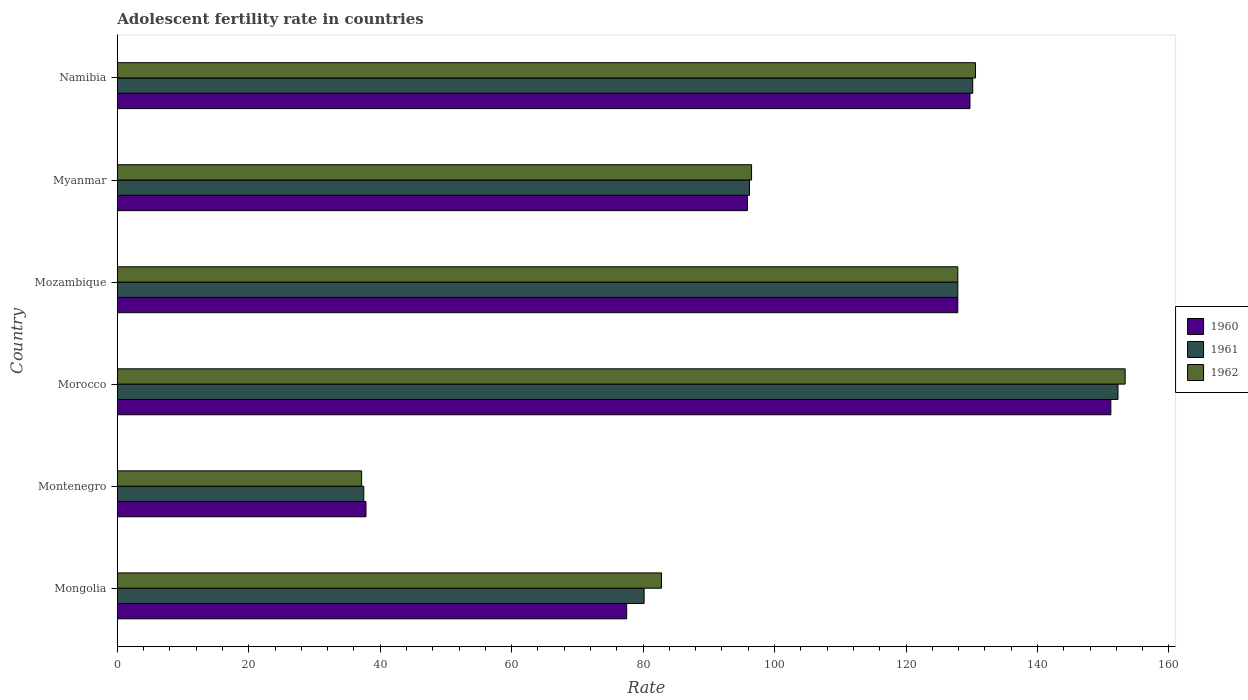How many different coloured bars are there?
Give a very brief answer. 3. Are the number of bars on each tick of the Y-axis equal?
Keep it short and to the point. Yes. How many bars are there on the 3rd tick from the bottom?
Your response must be concise. 3. What is the label of the 4th group of bars from the top?
Offer a terse response. Morocco. What is the adolescent fertility rate in 1961 in Morocco?
Provide a succinct answer. 152.25. Across all countries, what is the maximum adolescent fertility rate in 1961?
Offer a very short reply. 152.25. Across all countries, what is the minimum adolescent fertility rate in 1962?
Provide a succinct answer. 37.17. In which country was the adolescent fertility rate in 1960 maximum?
Give a very brief answer. Morocco. In which country was the adolescent fertility rate in 1961 minimum?
Keep it short and to the point. Montenegro. What is the total adolescent fertility rate in 1961 in the graph?
Ensure brevity in your answer.  624.12. What is the difference between the adolescent fertility rate in 1960 in Montenegro and that in Myanmar?
Make the answer very short. -58.03. What is the difference between the adolescent fertility rate in 1961 in Myanmar and the adolescent fertility rate in 1962 in Mongolia?
Give a very brief answer. 13.38. What is the average adolescent fertility rate in 1960 per country?
Keep it short and to the point. 103.33. What is the difference between the adolescent fertility rate in 1960 and adolescent fertility rate in 1962 in Myanmar?
Provide a succinct answer. -0.63. What is the ratio of the adolescent fertility rate in 1960 in Mozambique to that in Myanmar?
Your response must be concise. 1.33. Is the adolescent fertility rate in 1961 in Mongolia less than that in Montenegro?
Keep it short and to the point. No. What is the difference between the highest and the second highest adolescent fertility rate in 1962?
Provide a succinct answer. 22.77. What is the difference between the highest and the lowest adolescent fertility rate in 1961?
Offer a very short reply. 114.74. In how many countries, is the adolescent fertility rate in 1961 greater than the average adolescent fertility rate in 1961 taken over all countries?
Make the answer very short. 3. Is the sum of the adolescent fertility rate in 1962 in Montenegro and Namibia greater than the maximum adolescent fertility rate in 1960 across all countries?
Make the answer very short. Yes. What does the 1st bar from the top in Mongolia represents?
Offer a very short reply. 1962. What does the 1st bar from the bottom in Mozambique represents?
Offer a terse response. 1960. How many bars are there?
Ensure brevity in your answer.  18. Are all the bars in the graph horizontal?
Your response must be concise. Yes. Are the values on the major ticks of X-axis written in scientific E-notation?
Your answer should be compact. No. Does the graph contain any zero values?
Your answer should be compact. No. Does the graph contain grids?
Offer a terse response. No. How many legend labels are there?
Ensure brevity in your answer.  3. How are the legend labels stacked?
Your response must be concise. Vertical. What is the title of the graph?
Ensure brevity in your answer.  Adolescent fertility rate in countries. Does "1987" appear as one of the legend labels in the graph?
Keep it short and to the point. No. What is the label or title of the X-axis?
Ensure brevity in your answer.  Rate. What is the Rate in 1960 in Mongolia?
Provide a succinct answer. 77.5. What is the Rate in 1961 in Mongolia?
Offer a terse response. 80.15. What is the Rate in 1962 in Mongolia?
Your answer should be very brief. 82.8. What is the Rate in 1960 in Montenegro?
Your answer should be compact. 37.84. What is the Rate in 1961 in Montenegro?
Your answer should be very brief. 37.51. What is the Rate in 1962 in Montenegro?
Make the answer very short. 37.17. What is the Rate in 1960 in Morocco?
Your answer should be compact. 151.16. What is the Rate of 1961 in Morocco?
Provide a short and direct response. 152.25. What is the Rate of 1962 in Morocco?
Offer a very short reply. 153.34. What is the Rate in 1960 in Mozambique?
Your response must be concise. 127.88. What is the Rate of 1961 in Mozambique?
Offer a very short reply. 127.88. What is the Rate of 1962 in Mozambique?
Provide a short and direct response. 127.88. What is the Rate of 1960 in Myanmar?
Keep it short and to the point. 95.87. What is the Rate of 1961 in Myanmar?
Make the answer very short. 96.19. What is the Rate of 1962 in Myanmar?
Give a very brief answer. 96.5. What is the Rate in 1960 in Namibia?
Provide a succinct answer. 129.73. What is the Rate in 1961 in Namibia?
Keep it short and to the point. 130.15. What is the Rate in 1962 in Namibia?
Your response must be concise. 130.57. Across all countries, what is the maximum Rate of 1960?
Offer a very short reply. 151.16. Across all countries, what is the maximum Rate in 1961?
Your answer should be compact. 152.25. Across all countries, what is the maximum Rate in 1962?
Make the answer very short. 153.34. Across all countries, what is the minimum Rate in 1960?
Give a very brief answer. 37.84. Across all countries, what is the minimum Rate of 1961?
Offer a very short reply. 37.51. Across all countries, what is the minimum Rate in 1962?
Offer a terse response. 37.17. What is the total Rate of 1960 in the graph?
Make the answer very short. 619.98. What is the total Rate in 1961 in the graph?
Provide a short and direct response. 624.12. What is the total Rate in 1962 in the graph?
Keep it short and to the point. 628.27. What is the difference between the Rate of 1960 in Mongolia and that in Montenegro?
Offer a terse response. 39.66. What is the difference between the Rate in 1961 in Mongolia and that in Montenegro?
Offer a terse response. 42.65. What is the difference between the Rate in 1962 in Mongolia and that in Montenegro?
Keep it short and to the point. 45.63. What is the difference between the Rate in 1960 in Mongolia and that in Morocco?
Your response must be concise. -73.66. What is the difference between the Rate in 1961 in Mongolia and that in Morocco?
Give a very brief answer. -72.1. What is the difference between the Rate of 1962 in Mongolia and that in Morocco?
Your response must be concise. -70.54. What is the difference between the Rate of 1960 in Mongolia and that in Mozambique?
Provide a short and direct response. -50.38. What is the difference between the Rate of 1961 in Mongolia and that in Mozambique?
Your response must be concise. -47.73. What is the difference between the Rate of 1962 in Mongolia and that in Mozambique?
Your answer should be very brief. -45.08. What is the difference between the Rate of 1960 in Mongolia and that in Myanmar?
Your answer should be very brief. -18.37. What is the difference between the Rate of 1961 in Mongolia and that in Myanmar?
Your response must be concise. -16.03. What is the difference between the Rate of 1962 in Mongolia and that in Myanmar?
Keep it short and to the point. -13.7. What is the difference between the Rate of 1960 in Mongolia and that in Namibia?
Make the answer very short. -52.23. What is the difference between the Rate in 1961 in Mongolia and that in Namibia?
Ensure brevity in your answer.  -50. What is the difference between the Rate in 1962 in Mongolia and that in Namibia?
Your response must be concise. -47.77. What is the difference between the Rate in 1960 in Montenegro and that in Morocco?
Your answer should be very brief. -113.32. What is the difference between the Rate in 1961 in Montenegro and that in Morocco?
Provide a short and direct response. -114.74. What is the difference between the Rate in 1962 in Montenegro and that in Morocco?
Keep it short and to the point. -116.17. What is the difference between the Rate in 1960 in Montenegro and that in Mozambique?
Your answer should be compact. -90.04. What is the difference between the Rate of 1961 in Montenegro and that in Mozambique?
Your answer should be very brief. -90.37. What is the difference between the Rate of 1962 in Montenegro and that in Mozambique?
Ensure brevity in your answer.  -90.7. What is the difference between the Rate in 1960 in Montenegro and that in Myanmar?
Your response must be concise. -58.03. What is the difference between the Rate in 1961 in Montenegro and that in Myanmar?
Make the answer very short. -58.68. What is the difference between the Rate in 1962 in Montenegro and that in Myanmar?
Your answer should be very brief. -59.33. What is the difference between the Rate of 1960 in Montenegro and that in Namibia?
Keep it short and to the point. -91.89. What is the difference between the Rate of 1961 in Montenegro and that in Namibia?
Provide a short and direct response. -92.64. What is the difference between the Rate of 1962 in Montenegro and that in Namibia?
Make the answer very short. -93.4. What is the difference between the Rate of 1960 in Morocco and that in Mozambique?
Provide a succinct answer. 23.28. What is the difference between the Rate in 1961 in Morocco and that in Mozambique?
Ensure brevity in your answer.  24.37. What is the difference between the Rate in 1962 in Morocco and that in Mozambique?
Provide a succinct answer. 25.46. What is the difference between the Rate of 1960 in Morocco and that in Myanmar?
Your answer should be very brief. 55.29. What is the difference between the Rate in 1961 in Morocco and that in Myanmar?
Your answer should be compact. 56.06. What is the difference between the Rate of 1962 in Morocco and that in Myanmar?
Keep it short and to the point. 56.84. What is the difference between the Rate in 1960 in Morocco and that in Namibia?
Ensure brevity in your answer.  21.43. What is the difference between the Rate in 1961 in Morocco and that in Namibia?
Make the answer very short. 22.1. What is the difference between the Rate of 1962 in Morocco and that in Namibia?
Offer a very short reply. 22.77. What is the difference between the Rate in 1960 in Mozambique and that in Myanmar?
Make the answer very short. 32.01. What is the difference between the Rate of 1961 in Mozambique and that in Myanmar?
Make the answer very short. 31.69. What is the difference between the Rate in 1962 in Mozambique and that in Myanmar?
Provide a short and direct response. 31.38. What is the difference between the Rate of 1960 in Mozambique and that in Namibia?
Offer a terse response. -1.85. What is the difference between the Rate in 1961 in Mozambique and that in Namibia?
Offer a terse response. -2.27. What is the difference between the Rate in 1962 in Mozambique and that in Namibia?
Provide a succinct answer. -2.69. What is the difference between the Rate in 1960 in Myanmar and that in Namibia?
Your response must be concise. -33.86. What is the difference between the Rate of 1961 in Myanmar and that in Namibia?
Your answer should be compact. -33.97. What is the difference between the Rate in 1962 in Myanmar and that in Namibia?
Your answer should be very brief. -34.07. What is the difference between the Rate of 1960 in Mongolia and the Rate of 1961 in Montenegro?
Offer a terse response. 40. What is the difference between the Rate in 1960 in Mongolia and the Rate in 1962 in Montenegro?
Keep it short and to the point. 40.33. What is the difference between the Rate of 1961 in Mongolia and the Rate of 1962 in Montenegro?
Provide a short and direct response. 42.98. What is the difference between the Rate in 1960 in Mongolia and the Rate in 1961 in Morocco?
Keep it short and to the point. -74.75. What is the difference between the Rate of 1960 in Mongolia and the Rate of 1962 in Morocco?
Give a very brief answer. -75.84. What is the difference between the Rate of 1961 in Mongolia and the Rate of 1962 in Morocco?
Offer a very short reply. -73.19. What is the difference between the Rate in 1960 in Mongolia and the Rate in 1961 in Mozambique?
Provide a succinct answer. -50.38. What is the difference between the Rate of 1960 in Mongolia and the Rate of 1962 in Mozambique?
Your answer should be very brief. -50.38. What is the difference between the Rate of 1961 in Mongolia and the Rate of 1962 in Mozambique?
Ensure brevity in your answer.  -47.73. What is the difference between the Rate in 1960 in Mongolia and the Rate in 1961 in Myanmar?
Make the answer very short. -18.68. What is the difference between the Rate of 1960 in Mongolia and the Rate of 1962 in Myanmar?
Make the answer very short. -19. What is the difference between the Rate in 1961 in Mongolia and the Rate in 1962 in Myanmar?
Provide a succinct answer. -16.35. What is the difference between the Rate in 1960 in Mongolia and the Rate in 1961 in Namibia?
Your response must be concise. -52.65. What is the difference between the Rate in 1960 in Mongolia and the Rate in 1962 in Namibia?
Provide a short and direct response. -53.07. What is the difference between the Rate in 1961 in Mongolia and the Rate in 1962 in Namibia?
Give a very brief answer. -50.42. What is the difference between the Rate of 1960 in Montenegro and the Rate of 1961 in Morocco?
Offer a terse response. -114.41. What is the difference between the Rate of 1960 in Montenegro and the Rate of 1962 in Morocco?
Ensure brevity in your answer.  -115.5. What is the difference between the Rate in 1961 in Montenegro and the Rate in 1962 in Morocco?
Offer a terse response. -115.83. What is the difference between the Rate in 1960 in Montenegro and the Rate in 1961 in Mozambique?
Offer a terse response. -90.04. What is the difference between the Rate of 1960 in Montenegro and the Rate of 1962 in Mozambique?
Your response must be concise. -90.04. What is the difference between the Rate of 1961 in Montenegro and the Rate of 1962 in Mozambique?
Provide a short and direct response. -90.37. What is the difference between the Rate of 1960 in Montenegro and the Rate of 1961 in Myanmar?
Your answer should be very brief. -58.35. What is the difference between the Rate of 1960 in Montenegro and the Rate of 1962 in Myanmar?
Your answer should be compact. -58.66. What is the difference between the Rate of 1961 in Montenegro and the Rate of 1962 in Myanmar?
Offer a very short reply. -59. What is the difference between the Rate of 1960 in Montenegro and the Rate of 1961 in Namibia?
Your response must be concise. -92.31. What is the difference between the Rate of 1960 in Montenegro and the Rate of 1962 in Namibia?
Make the answer very short. -92.73. What is the difference between the Rate of 1961 in Montenegro and the Rate of 1962 in Namibia?
Offer a very short reply. -93.07. What is the difference between the Rate of 1960 in Morocco and the Rate of 1961 in Mozambique?
Provide a short and direct response. 23.28. What is the difference between the Rate in 1960 in Morocco and the Rate in 1962 in Mozambique?
Make the answer very short. 23.28. What is the difference between the Rate in 1961 in Morocco and the Rate in 1962 in Mozambique?
Provide a succinct answer. 24.37. What is the difference between the Rate in 1960 in Morocco and the Rate in 1961 in Myanmar?
Provide a succinct answer. 54.98. What is the difference between the Rate of 1960 in Morocco and the Rate of 1962 in Myanmar?
Keep it short and to the point. 54.66. What is the difference between the Rate of 1961 in Morocco and the Rate of 1962 in Myanmar?
Provide a succinct answer. 55.75. What is the difference between the Rate of 1960 in Morocco and the Rate of 1961 in Namibia?
Your answer should be very brief. 21.01. What is the difference between the Rate in 1960 in Morocco and the Rate in 1962 in Namibia?
Provide a short and direct response. 20.59. What is the difference between the Rate in 1961 in Morocco and the Rate in 1962 in Namibia?
Provide a short and direct response. 21.68. What is the difference between the Rate of 1960 in Mozambique and the Rate of 1961 in Myanmar?
Provide a short and direct response. 31.69. What is the difference between the Rate of 1960 in Mozambique and the Rate of 1962 in Myanmar?
Make the answer very short. 31.38. What is the difference between the Rate in 1961 in Mozambique and the Rate in 1962 in Myanmar?
Provide a short and direct response. 31.38. What is the difference between the Rate of 1960 in Mozambique and the Rate of 1961 in Namibia?
Offer a very short reply. -2.27. What is the difference between the Rate in 1960 in Mozambique and the Rate in 1962 in Namibia?
Give a very brief answer. -2.69. What is the difference between the Rate in 1961 in Mozambique and the Rate in 1962 in Namibia?
Provide a short and direct response. -2.69. What is the difference between the Rate of 1960 in Myanmar and the Rate of 1961 in Namibia?
Your answer should be compact. -34.28. What is the difference between the Rate in 1960 in Myanmar and the Rate in 1962 in Namibia?
Provide a succinct answer. -34.7. What is the difference between the Rate of 1961 in Myanmar and the Rate of 1962 in Namibia?
Your answer should be compact. -34.39. What is the average Rate in 1960 per country?
Your response must be concise. 103.33. What is the average Rate in 1961 per country?
Offer a very short reply. 104.02. What is the average Rate in 1962 per country?
Provide a short and direct response. 104.71. What is the difference between the Rate of 1960 and Rate of 1961 in Mongolia?
Keep it short and to the point. -2.65. What is the difference between the Rate in 1960 and Rate in 1962 in Mongolia?
Provide a short and direct response. -5.3. What is the difference between the Rate of 1961 and Rate of 1962 in Mongolia?
Make the answer very short. -2.65. What is the difference between the Rate in 1960 and Rate in 1961 in Montenegro?
Provide a succinct answer. 0.33. What is the difference between the Rate in 1960 and Rate in 1962 in Montenegro?
Offer a terse response. 0.66. What is the difference between the Rate of 1961 and Rate of 1962 in Montenegro?
Provide a succinct answer. 0.33. What is the difference between the Rate of 1960 and Rate of 1961 in Morocco?
Offer a terse response. -1.09. What is the difference between the Rate in 1960 and Rate in 1962 in Morocco?
Ensure brevity in your answer.  -2.18. What is the difference between the Rate in 1961 and Rate in 1962 in Morocco?
Offer a very short reply. -1.09. What is the difference between the Rate of 1960 and Rate of 1962 in Mozambique?
Keep it short and to the point. 0. What is the difference between the Rate in 1960 and Rate in 1961 in Myanmar?
Provide a short and direct response. -0.32. What is the difference between the Rate of 1960 and Rate of 1962 in Myanmar?
Give a very brief answer. -0.63. What is the difference between the Rate in 1961 and Rate in 1962 in Myanmar?
Provide a succinct answer. -0.32. What is the difference between the Rate in 1960 and Rate in 1961 in Namibia?
Give a very brief answer. -0.42. What is the difference between the Rate in 1960 and Rate in 1962 in Namibia?
Offer a very short reply. -0.84. What is the difference between the Rate in 1961 and Rate in 1962 in Namibia?
Your answer should be compact. -0.42. What is the ratio of the Rate in 1960 in Mongolia to that in Montenegro?
Keep it short and to the point. 2.05. What is the ratio of the Rate in 1961 in Mongolia to that in Montenegro?
Provide a short and direct response. 2.14. What is the ratio of the Rate in 1962 in Mongolia to that in Montenegro?
Ensure brevity in your answer.  2.23. What is the ratio of the Rate of 1960 in Mongolia to that in Morocco?
Provide a succinct answer. 0.51. What is the ratio of the Rate of 1961 in Mongolia to that in Morocco?
Provide a short and direct response. 0.53. What is the ratio of the Rate in 1962 in Mongolia to that in Morocco?
Keep it short and to the point. 0.54. What is the ratio of the Rate in 1960 in Mongolia to that in Mozambique?
Offer a terse response. 0.61. What is the ratio of the Rate of 1961 in Mongolia to that in Mozambique?
Give a very brief answer. 0.63. What is the ratio of the Rate in 1962 in Mongolia to that in Mozambique?
Make the answer very short. 0.65. What is the ratio of the Rate in 1960 in Mongolia to that in Myanmar?
Keep it short and to the point. 0.81. What is the ratio of the Rate of 1961 in Mongolia to that in Myanmar?
Your response must be concise. 0.83. What is the ratio of the Rate of 1962 in Mongolia to that in Myanmar?
Make the answer very short. 0.86. What is the ratio of the Rate in 1960 in Mongolia to that in Namibia?
Provide a succinct answer. 0.6. What is the ratio of the Rate in 1961 in Mongolia to that in Namibia?
Your answer should be very brief. 0.62. What is the ratio of the Rate in 1962 in Mongolia to that in Namibia?
Your response must be concise. 0.63. What is the ratio of the Rate of 1960 in Montenegro to that in Morocco?
Make the answer very short. 0.25. What is the ratio of the Rate in 1961 in Montenegro to that in Morocco?
Make the answer very short. 0.25. What is the ratio of the Rate in 1962 in Montenegro to that in Morocco?
Your answer should be compact. 0.24. What is the ratio of the Rate of 1960 in Montenegro to that in Mozambique?
Make the answer very short. 0.3. What is the ratio of the Rate in 1961 in Montenegro to that in Mozambique?
Provide a succinct answer. 0.29. What is the ratio of the Rate in 1962 in Montenegro to that in Mozambique?
Offer a terse response. 0.29. What is the ratio of the Rate of 1960 in Montenegro to that in Myanmar?
Your response must be concise. 0.39. What is the ratio of the Rate of 1961 in Montenegro to that in Myanmar?
Offer a very short reply. 0.39. What is the ratio of the Rate of 1962 in Montenegro to that in Myanmar?
Your answer should be very brief. 0.39. What is the ratio of the Rate in 1960 in Montenegro to that in Namibia?
Ensure brevity in your answer.  0.29. What is the ratio of the Rate of 1961 in Montenegro to that in Namibia?
Your answer should be compact. 0.29. What is the ratio of the Rate in 1962 in Montenegro to that in Namibia?
Make the answer very short. 0.28. What is the ratio of the Rate in 1960 in Morocco to that in Mozambique?
Your answer should be very brief. 1.18. What is the ratio of the Rate in 1961 in Morocco to that in Mozambique?
Keep it short and to the point. 1.19. What is the ratio of the Rate of 1962 in Morocco to that in Mozambique?
Give a very brief answer. 1.2. What is the ratio of the Rate in 1960 in Morocco to that in Myanmar?
Offer a very short reply. 1.58. What is the ratio of the Rate of 1961 in Morocco to that in Myanmar?
Ensure brevity in your answer.  1.58. What is the ratio of the Rate of 1962 in Morocco to that in Myanmar?
Your answer should be compact. 1.59. What is the ratio of the Rate of 1960 in Morocco to that in Namibia?
Your response must be concise. 1.17. What is the ratio of the Rate of 1961 in Morocco to that in Namibia?
Give a very brief answer. 1.17. What is the ratio of the Rate in 1962 in Morocco to that in Namibia?
Your answer should be compact. 1.17. What is the ratio of the Rate of 1960 in Mozambique to that in Myanmar?
Offer a terse response. 1.33. What is the ratio of the Rate of 1961 in Mozambique to that in Myanmar?
Your answer should be compact. 1.33. What is the ratio of the Rate of 1962 in Mozambique to that in Myanmar?
Provide a succinct answer. 1.33. What is the ratio of the Rate of 1960 in Mozambique to that in Namibia?
Offer a terse response. 0.99. What is the ratio of the Rate of 1961 in Mozambique to that in Namibia?
Your answer should be very brief. 0.98. What is the ratio of the Rate of 1962 in Mozambique to that in Namibia?
Provide a succinct answer. 0.98. What is the ratio of the Rate of 1960 in Myanmar to that in Namibia?
Make the answer very short. 0.74. What is the ratio of the Rate in 1961 in Myanmar to that in Namibia?
Give a very brief answer. 0.74. What is the ratio of the Rate of 1962 in Myanmar to that in Namibia?
Your answer should be compact. 0.74. What is the difference between the highest and the second highest Rate of 1960?
Your response must be concise. 21.43. What is the difference between the highest and the second highest Rate in 1961?
Your response must be concise. 22.1. What is the difference between the highest and the second highest Rate of 1962?
Your answer should be very brief. 22.77. What is the difference between the highest and the lowest Rate of 1960?
Provide a short and direct response. 113.32. What is the difference between the highest and the lowest Rate of 1961?
Your response must be concise. 114.74. What is the difference between the highest and the lowest Rate of 1962?
Ensure brevity in your answer.  116.17. 